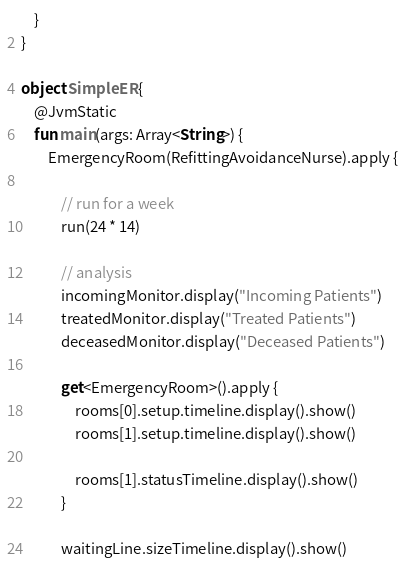<code> <loc_0><loc_0><loc_500><loc_500><_Kotlin_>    }
}

object SimpleER {
    @JvmStatic
    fun main(args: Array<String>) {
        EmergencyRoom(RefittingAvoidanceNurse).apply {

            // run for a week
            run(24 * 14)

            // analysis
            incomingMonitor.display("Incoming Patients")
            treatedMonitor.display("Treated Patients")
            deceasedMonitor.display("Deceased Patients")

            get<EmergencyRoom>().apply {
                rooms[0].setup.timeline.display().show()
                rooms[1].setup.timeline.display().show()

                rooms[1].statusTimeline.display().show()
            }

            waitingLine.sizeTimeline.display().show()</code> 